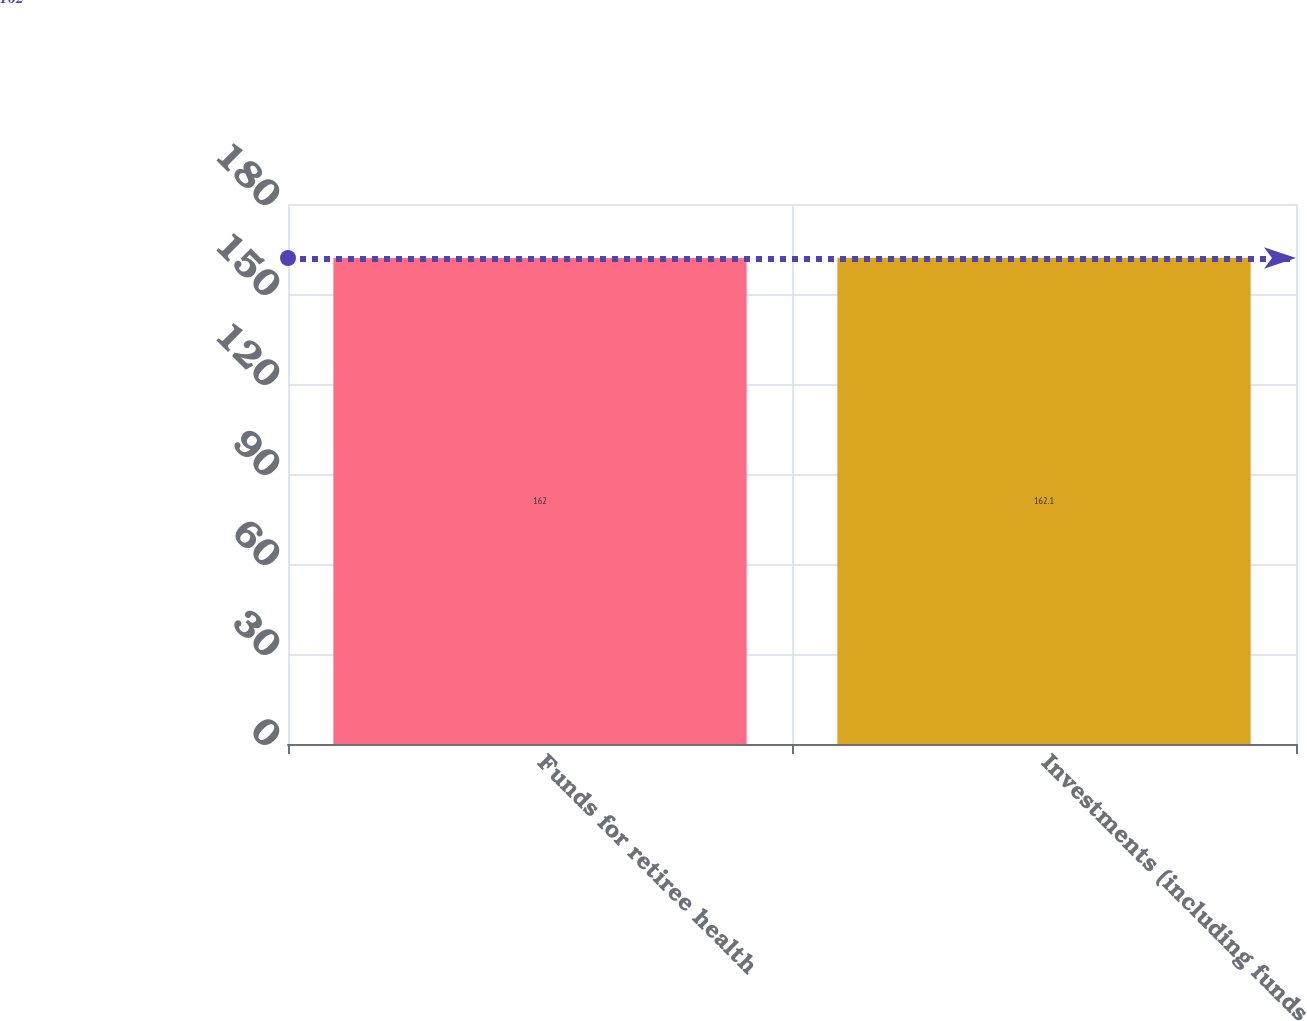Convert chart. <chart><loc_0><loc_0><loc_500><loc_500><bar_chart><fcel>Funds for retiree health<fcel>Investments (including funds<nl><fcel>162<fcel>162.1<nl></chart> 